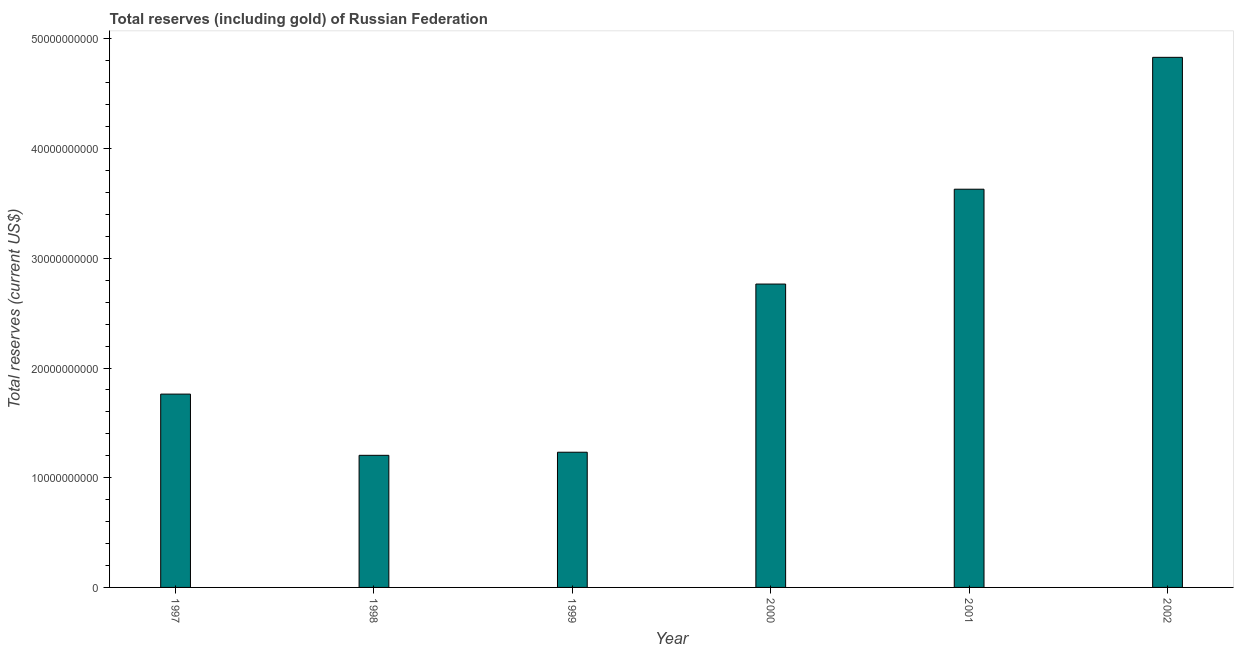Does the graph contain any zero values?
Keep it short and to the point. No. What is the title of the graph?
Provide a short and direct response. Total reserves (including gold) of Russian Federation. What is the label or title of the Y-axis?
Provide a short and direct response. Total reserves (current US$). What is the total reserves (including gold) in 1999?
Make the answer very short. 1.23e+1. Across all years, what is the maximum total reserves (including gold)?
Your answer should be very brief. 4.83e+1. Across all years, what is the minimum total reserves (including gold)?
Make the answer very short. 1.20e+1. In which year was the total reserves (including gold) maximum?
Your answer should be very brief. 2002. What is the sum of the total reserves (including gold)?
Ensure brevity in your answer.  1.54e+11. What is the difference between the total reserves (including gold) in 1997 and 2002?
Provide a short and direct response. -3.07e+1. What is the average total reserves (including gold) per year?
Your answer should be very brief. 2.57e+1. What is the median total reserves (including gold)?
Provide a short and direct response. 2.26e+1. What is the ratio of the total reserves (including gold) in 2001 to that in 2002?
Give a very brief answer. 0.75. Is the total reserves (including gold) in 1997 less than that in 2002?
Give a very brief answer. Yes. What is the difference between the highest and the second highest total reserves (including gold)?
Your answer should be compact. 1.20e+1. What is the difference between the highest and the lowest total reserves (including gold)?
Your answer should be very brief. 3.63e+1. In how many years, is the total reserves (including gold) greater than the average total reserves (including gold) taken over all years?
Offer a very short reply. 3. How many bars are there?
Give a very brief answer. 6. Are all the bars in the graph horizontal?
Offer a very short reply. No. What is the Total reserves (current US$) of 1997?
Your answer should be compact. 1.76e+1. What is the Total reserves (current US$) of 1998?
Make the answer very short. 1.20e+1. What is the Total reserves (current US$) in 1999?
Ensure brevity in your answer.  1.23e+1. What is the Total reserves (current US$) of 2000?
Keep it short and to the point. 2.77e+1. What is the Total reserves (current US$) in 2001?
Provide a short and direct response. 3.63e+1. What is the Total reserves (current US$) of 2002?
Offer a terse response. 4.83e+1. What is the difference between the Total reserves (current US$) in 1997 and 1998?
Your answer should be very brief. 5.58e+09. What is the difference between the Total reserves (current US$) in 1997 and 1999?
Ensure brevity in your answer.  5.30e+09. What is the difference between the Total reserves (current US$) in 1997 and 2000?
Offer a terse response. -1.00e+1. What is the difference between the Total reserves (current US$) in 1997 and 2001?
Give a very brief answer. -1.87e+1. What is the difference between the Total reserves (current US$) in 1997 and 2002?
Your answer should be very brief. -3.07e+1. What is the difference between the Total reserves (current US$) in 1998 and 1999?
Make the answer very short. -2.82e+08. What is the difference between the Total reserves (current US$) in 1998 and 2000?
Provide a succinct answer. -1.56e+1. What is the difference between the Total reserves (current US$) in 1998 and 2001?
Provide a short and direct response. -2.43e+1. What is the difference between the Total reserves (current US$) in 1998 and 2002?
Your answer should be very brief. -3.63e+1. What is the difference between the Total reserves (current US$) in 1999 and 2000?
Ensure brevity in your answer.  -1.53e+1. What is the difference between the Total reserves (current US$) in 1999 and 2001?
Offer a terse response. -2.40e+1. What is the difference between the Total reserves (current US$) in 1999 and 2002?
Offer a terse response. -3.60e+1. What is the difference between the Total reserves (current US$) in 2000 and 2001?
Your response must be concise. -8.65e+09. What is the difference between the Total reserves (current US$) in 2000 and 2002?
Make the answer very short. -2.07e+1. What is the difference between the Total reserves (current US$) in 2001 and 2002?
Your answer should be very brief. -1.20e+1. What is the ratio of the Total reserves (current US$) in 1997 to that in 1998?
Your answer should be compact. 1.46. What is the ratio of the Total reserves (current US$) in 1997 to that in 1999?
Give a very brief answer. 1.43. What is the ratio of the Total reserves (current US$) in 1997 to that in 2000?
Provide a succinct answer. 0.64. What is the ratio of the Total reserves (current US$) in 1997 to that in 2001?
Keep it short and to the point. 0.48. What is the ratio of the Total reserves (current US$) in 1997 to that in 2002?
Offer a very short reply. 0.36. What is the ratio of the Total reserves (current US$) in 1998 to that in 1999?
Give a very brief answer. 0.98. What is the ratio of the Total reserves (current US$) in 1998 to that in 2000?
Provide a succinct answer. 0.43. What is the ratio of the Total reserves (current US$) in 1998 to that in 2001?
Make the answer very short. 0.33. What is the ratio of the Total reserves (current US$) in 1998 to that in 2002?
Offer a very short reply. 0.25. What is the ratio of the Total reserves (current US$) in 1999 to that in 2000?
Ensure brevity in your answer.  0.45. What is the ratio of the Total reserves (current US$) in 1999 to that in 2001?
Make the answer very short. 0.34. What is the ratio of the Total reserves (current US$) in 1999 to that in 2002?
Make the answer very short. 0.26. What is the ratio of the Total reserves (current US$) in 2000 to that in 2001?
Your answer should be compact. 0.76. What is the ratio of the Total reserves (current US$) in 2000 to that in 2002?
Offer a very short reply. 0.57. What is the ratio of the Total reserves (current US$) in 2001 to that in 2002?
Provide a succinct answer. 0.75. 